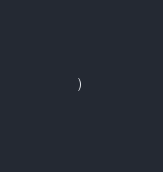<code> <loc_0><loc_0><loc_500><loc_500><_SQL_>) 
</code> 